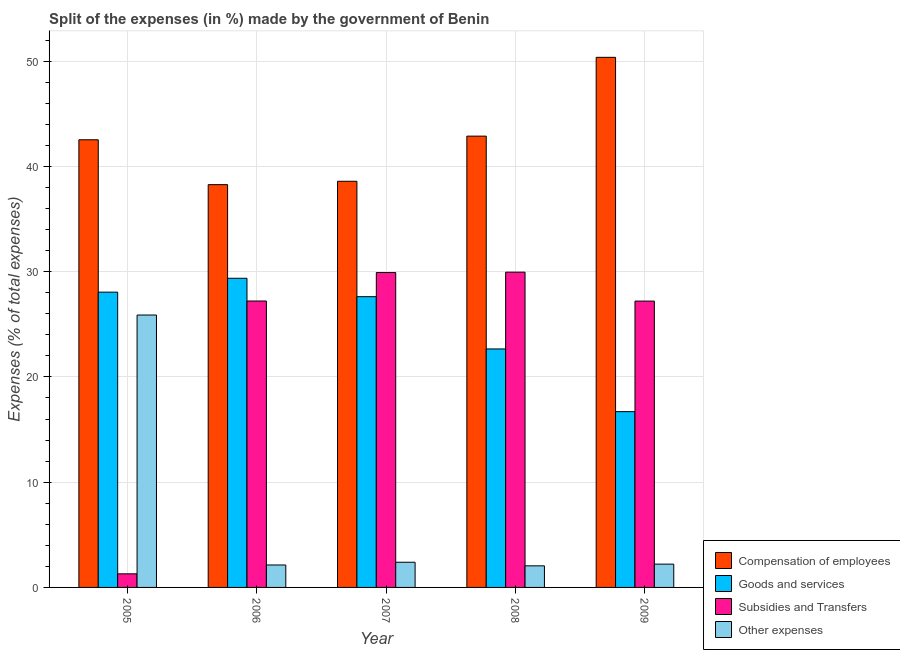How many different coloured bars are there?
Offer a terse response. 4. Are the number of bars per tick equal to the number of legend labels?
Offer a very short reply. Yes. Are the number of bars on each tick of the X-axis equal?
Provide a short and direct response. Yes. How many bars are there on the 2nd tick from the left?
Keep it short and to the point. 4. What is the label of the 2nd group of bars from the left?
Provide a short and direct response. 2006. What is the percentage of amount spent on subsidies in 2008?
Make the answer very short. 29.95. Across all years, what is the maximum percentage of amount spent on other expenses?
Provide a succinct answer. 25.88. Across all years, what is the minimum percentage of amount spent on compensation of employees?
Provide a succinct answer. 38.26. What is the total percentage of amount spent on compensation of employees in the graph?
Your answer should be compact. 212.61. What is the difference between the percentage of amount spent on compensation of employees in 2005 and that in 2007?
Make the answer very short. 3.94. What is the difference between the percentage of amount spent on compensation of employees in 2005 and the percentage of amount spent on goods and services in 2008?
Offer a terse response. -0.35. What is the average percentage of amount spent on compensation of employees per year?
Provide a succinct answer. 42.52. What is the ratio of the percentage of amount spent on compensation of employees in 2007 to that in 2008?
Your answer should be very brief. 0.9. What is the difference between the highest and the second highest percentage of amount spent on subsidies?
Make the answer very short. 0.03. What is the difference between the highest and the lowest percentage of amount spent on subsidies?
Your response must be concise. 28.66. In how many years, is the percentage of amount spent on compensation of employees greater than the average percentage of amount spent on compensation of employees taken over all years?
Provide a short and direct response. 3. What does the 3rd bar from the left in 2009 represents?
Offer a terse response. Subsidies and Transfers. What does the 2nd bar from the right in 2007 represents?
Ensure brevity in your answer.  Subsidies and Transfers. How many bars are there?
Give a very brief answer. 20. Are all the bars in the graph horizontal?
Offer a very short reply. No. Are the values on the major ticks of Y-axis written in scientific E-notation?
Give a very brief answer. No. Does the graph contain any zero values?
Offer a terse response. No. Where does the legend appear in the graph?
Your answer should be compact. Bottom right. How many legend labels are there?
Ensure brevity in your answer.  4. How are the legend labels stacked?
Make the answer very short. Vertical. What is the title of the graph?
Offer a terse response. Split of the expenses (in %) made by the government of Benin. What is the label or title of the X-axis?
Ensure brevity in your answer.  Year. What is the label or title of the Y-axis?
Your answer should be compact. Expenses (% of total expenses). What is the Expenses (% of total expenses) in Compensation of employees in 2005?
Your answer should be compact. 42.53. What is the Expenses (% of total expenses) in Goods and services in 2005?
Ensure brevity in your answer.  28.05. What is the Expenses (% of total expenses) in Subsidies and Transfers in 2005?
Keep it short and to the point. 1.29. What is the Expenses (% of total expenses) of Other expenses in 2005?
Offer a terse response. 25.88. What is the Expenses (% of total expenses) of Compensation of employees in 2006?
Your response must be concise. 38.26. What is the Expenses (% of total expenses) in Goods and services in 2006?
Your response must be concise. 29.37. What is the Expenses (% of total expenses) of Subsidies and Transfers in 2006?
Make the answer very short. 27.21. What is the Expenses (% of total expenses) in Other expenses in 2006?
Offer a very short reply. 2.13. What is the Expenses (% of total expenses) of Compensation of employees in 2007?
Keep it short and to the point. 38.59. What is the Expenses (% of total expenses) in Goods and services in 2007?
Offer a very short reply. 27.62. What is the Expenses (% of total expenses) of Subsidies and Transfers in 2007?
Offer a very short reply. 29.92. What is the Expenses (% of total expenses) of Other expenses in 2007?
Your answer should be compact. 2.39. What is the Expenses (% of total expenses) in Compensation of employees in 2008?
Make the answer very short. 42.87. What is the Expenses (% of total expenses) of Goods and services in 2008?
Your answer should be very brief. 22.66. What is the Expenses (% of total expenses) in Subsidies and Transfers in 2008?
Give a very brief answer. 29.95. What is the Expenses (% of total expenses) of Other expenses in 2008?
Your answer should be very brief. 2.05. What is the Expenses (% of total expenses) of Compensation of employees in 2009?
Offer a terse response. 50.36. What is the Expenses (% of total expenses) in Goods and services in 2009?
Your answer should be compact. 16.7. What is the Expenses (% of total expenses) of Subsidies and Transfers in 2009?
Your response must be concise. 27.2. What is the Expenses (% of total expenses) of Other expenses in 2009?
Ensure brevity in your answer.  2.21. Across all years, what is the maximum Expenses (% of total expenses) of Compensation of employees?
Your answer should be very brief. 50.36. Across all years, what is the maximum Expenses (% of total expenses) in Goods and services?
Make the answer very short. 29.37. Across all years, what is the maximum Expenses (% of total expenses) in Subsidies and Transfers?
Your response must be concise. 29.95. Across all years, what is the maximum Expenses (% of total expenses) in Other expenses?
Your answer should be very brief. 25.88. Across all years, what is the minimum Expenses (% of total expenses) of Compensation of employees?
Make the answer very short. 38.26. Across all years, what is the minimum Expenses (% of total expenses) in Goods and services?
Your answer should be compact. 16.7. Across all years, what is the minimum Expenses (% of total expenses) in Subsidies and Transfers?
Ensure brevity in your answer.  1.29. Across all years, what is the minimum Expenses (% of total expenses) of Other expenses?
Your answer should be very brief. 2.05. What is the total Expenses (% of total expenses) in Compensation of employees in the graph?
Provide a succinct answer. 212.61. What is the total Expenses (% of total expenses) in Goods and services in the graph?
Offer a very short reply. 124.4. What is the total Expenses (% of total expenses) of Subsidies and Transfers in the graph?
Your response must be concise. 115.57. What is the total Expenses (% of total expenses) of Other expenses in the graph?
Your answer should be compact. 34.67. What is the difference between the Expenses (% of total expenses) in Compensation of employees in 2005 and that in 2006?
Your response must be concise. 4.26. What is the difference between the Expenses (% of total expenses) of Goods and services in 2005 and that in 2006?
Make the answer very short. -1.32. What is the difference between the Expenses (% of total expenses) of Subsidies and Transfers in 2005 and that in 2006?
Your answer should be compact. -25.92. What is the difference between the Expenses (% of total expenses) of Other expenses in 2005 and that in 2006?
Keep it short and to the point. 23.75. What is the difference between the Expenses (% of total expenses) in Compensation of employees in 2005 and that in 2007?
Your answer should be very brief. 3.94. What is the difference between the Expenses (% of total expenses) of Goods and services in 2005 and that in 2007?
Your answer should be very brief. 0.43. What is the difference between the Expenses (% of total expenses) in Subsidies and Transfers in 2005 and that in 2007?
Offer a very short reply. -28.62. What is the difference between the Expenses (% of total expenses) in Other expenses in 2005 and that in 2007?
Provide a short and direct response. 23.49. What is the difference between the Expenses (% of total expenses) of Compensation of employees in 2005 and that in 2008?
Your answer should be very brief. -0.35. What is the difference between the Expenses (% of total expenses) in Goods and services in 2005 and that in 2008?
Provide a succinct answer. 5.4. What is the difference between the Expenses (% of total expenses) in Subsidies and Transfers in 2005 and that in 2008?
Ensure brevity in your answer.  -28.66. What is the difference between the Expenses (% of total expenses) of Other expenses in 2005 and that in 2008?
Your answer should be very brief. 23.83. What is the difference between the Expenses (% of total expenses) in Compensation of employees in 2005 and that in 2009?
Your response must be concise. -7.83. What is the difference between the Expenses (% of total expenses) of Goods and services in 2005 and that in 2009?
Keep it short and to the point. 11.35. What is the difference between the Expenses (% of total expenses) in Subsidies and Transfers in 2005 and that in 2009?
Your answer should be very brief. -25.91. What is the difference between the Expenses (% of total expenses) of Other expenses in 2005 and that in 2009?
Provide a succinct answer. 23.67. What is the difference between the Expenses (% of total expenses) of Compensation of employees in 2006 and that in 2007?
Offer a very short reply. -0.32. What is the difference between the Expenses (% of total expenses) in Goods and services in 2006 and that in 2007?
Offer a terse response. 1.75. What is the difference between the Expenses (% of total expenses) of Subsidies and Transfers in 2006 and that in 2007?
Ensure brevity in your answer.  -2.71. What is the difference between the Expenses (% of total expenses) of Other expenses in 2006 and that in 2007?
Give a very brief answer. -0.26. What is the difference between the Expenses (% of total expenses) in Compensation of employees in 2006 and that in 2008?
Give a very brief answer. -4.61. What is the difference between the Expenses (% of total expenses) in Goods and services in 2006 and that in 2008?
Provide a succinct answer. 6.71. What is the difference between the Expenses (% of total expenses) in Subsidies and Transfers in 2006 and that in 2008?
Your response must be concise. -2.74. What is the difference between the Expenses (% of total expenses) in Other expenses in 2006 and that in 2008?
Your answer should be compact. 0.08. What is the difference between the Expenses (% of total expenses) in Compensation of employees in 2006 and that in 2009?
Your answer should be compact. -12.1. What is the difference between the Expenses (% of total expenses) in Goods and services in 2006 and that in 2009?
Your response must be concise. 12.67. What is the difference between the Expenses (% of total expenses) in Subsidies and Transfers in 2006 and that in 2009?
Give a very brief answer. 0.01. What is the difference between the Expenses (% of total expenses) in Other expenses in 2006 and that in 2009?
Provide a succinct answer. -0.08. What is the difference between the Expenses (% of total expenses) in Compensation of employees in 2007 and that in 2008?
Keep it short and to the point. -4.29. What is the difference between the Expenses (% of total expenses) of Goods and services in 2007 and that in 2008?
Ensure brevity in your answer.  4.97. What is the difference between the Expenses (% of total expenses) of Subsidies and Transfers in 2007 and that in 2008?
Offer a terse response. -0.03. What is the difference between the Expenses (% of total expenses) in Other expenses in 2007 and that in 2008?
Make the answer very short. 0.34. What is the difference between the Expenses (% of total expenses) in Compensation of employees in 2007 and that in 2009?
Offer a very short reply. -11.78. What is the difference between the Expenses (% of total expenses) in Goods and services in 2007 and that in 2009?
Provide a short and direct response. 10.92. What is the difference between the Expenses (% of total expenses) in Subsidies and Transfers in 2007 and that in 2009?
Give a very brief answer. 2.71. What is the difference between the Expenses (% of total expenses) in Other expenses in 2007 and that in 2009?
Offer a very short reply. 0.18. What is the difference between the Expenses (% of total expenses) in Compensation of employees in 2008 and that in 2009?
Ensure brevity in your answer.  -7.49. What is the difference between the Expenses (% of total expenses) of Goods and services in 2008 and that in 2009?
Your answer should be very brief. 5.96. What is the difference between the Expenses (% of total expenses) of Subsidies and Transfers in 2008 and that in 2009?
Offer a terse response. 2.75. What is the difference between the Expenses (% of total expenses) of Other expenses in 2008 and that in 2009?
Give a very brief answer. -0.16. What is the difference between the Expenses (% of total expenses) of Compensation of employees in 2005 and the Expenses (% of total expenses) of Goods and services in 2006?
Offer a terse response. 13.16. What is the difference between the Expenses (% of total expenses) in Compensation of employees in 2005 and the Expenses (% of total expenses) in Subsidies and Transfers in 2006?
Your answer should be compact. 15.32. What is the difference between the Expenses (% of total expenses) in Compensation of employees in 2005 and the Expenses (% of total expenses) in Other expenses in 2006?
Provide a succinct answer. 40.39. What is the difference between the Expenses (% of total expenses) of Goods and services in 2005 and the Expenses (% of total expenses) of Subsidies and Transfers in 2006?
Provide a short and direct response. 0.84. What is the difference between the Expenses (% of total expenses) of Goods and services in 2005 and the Expenses (% of total expenses) of Other expenses in 2006?
Give a very brief answer. 25.92. What is the difference between the Expenses (% of total expenses) in Subsidies and Transfers in 2005 and the Expenses (% of total expenses) in Other expenses in 2006?
Provide a short and direct response. -0.84. What is the difference between the Expenses (% of total expenses) of Compensation of employees in 2005 and the Expenses (% of total expenses) of Goods and services in 2007?
Your answer should be compact. 14.91. What is the difference between the Expenses (% of total expenses) in Compensation of employees in 2005 and the Expenses (% of total expenses) in Subsidies and Transfers in 2007?
Your answer should be compact. 12.61. What is the difference between the Expenses (% of total expenses) in Compensation of employees in 2005 and the Expenses (% of total expenses) in Other expenses in 2007?
Keep it short and to the point. 40.14. What is the difference between the Expenses (% of total expenses) of Goods and services in 2005 and the Expenses (% of total expenses) of Subsidies and Transfers in 2007?
Provide a short and direct response. -1.86. What is the difference between the Expenses (% of total expenses) in Goods and services in 2005 and the Expenses (% of total expenses) in Other expenses in 2007?
Provide a short and direct response. 25.66. What is the difference between the Expenses (% of total expenses) in Subsidies and Transfers in 2005 and the Expenses (% of total expenses) in Other expenses in 2007?
Your response must be concise. -1.1. What is the difference between the Expenses (% of total expenses) of Compensation of employees in 2005 and the Expenses (% of total expenses) of Goods and services in 2008?
Your answer should be very brief. 19.87. What is the difference between the Expenses (% of total expenses) in Compensation of employees in 2005 and the Expenses (% of total expenses) in Subsidies and Transfers in 2008?
Provide a short and direct response. 12.58. What is the difference between the Expenses (% of total expenses) of Compensation of employees in 2005 and the Expenses (% of total expenses) of Other expenses in 2008?
Ensure brevity in your answer.  40.48. What is the difference between the Expenses (% of total expenses) in Goods and services in 2005 and the Expenses (% of total expenses) in Subsidies and Transfers in 2008?
Your response must be concise. -1.9. What is the difference between the Expenses (% of total expenses) in Goods and services in 2005 and the Expenses (% of total expenses) in Other expenses in 2008?
Offer a terse response. 26. What is the difference between the Expenses (% of total expenses) in Subsidies and Transfers in 2005 and the Expenses (% of total expenses) in Other expenses in 2008?
Ensure brevity in your answer.  -0.76. What is the difference between the Expenses (% of total expenses) in Compensation of employees in 2005 and the Expenses (% of total expenses) in Goods and services in 2009?
Give a very brief answer. 25.83. What is the difference between the Expenses (% of total expenses) of Compensation of employees in 2005 and the Expenses (% of total expenses) of Subsidies and Transfers in 2009?
Give a very brief answer. 15.32. What is the difference between the Expenses (% of total expenses) of Compensation of employees in 2005 and the Expenses (% of total expenses) of Other expenses in 2009?
Make the answer very short. 40.31. What is the difference between the Expenses (% of total expenses) of Goods and services in 2005 and the Expenses (% of total expenses) of Subsidies and Transfers in 2009?
Give a very brief answer. 0.85. What is the difference between the Expenses (% of total expenses) of Goods and services in 2005 and the Expenses (% of total expenses) of Other expenses in 2009?
Keep it short and to the point. 25.84. What is the difference between the Expenses (% of total expenses) in Subsidies and Transfers in 2005 and the Expenses (% of total expenses) in Other expenses in 2009?
Provide a succinct answer. -0.92. What is the difference between the Expenses (% of total expenses) in Compensation of employees in 2006 and the Expenses (% of total expenses) in Goods and services in 2007?
Offer a very short reply. 10.64. What is the difference between the Expenses (% of total expenses) of Compensation of employees in 2006 and the Expenses (% of total expenses) of Subsidies and Transfers in 2007?
Provide a succinct answer. 8.35. What is the difference between the Expenses (% of total expenses) of Compensation of employees in 2006 and the Expenses (% of total expenses) of Other expenses in 2007?
Your answer should be compact. 35.87. What is the difference between the Expenses (% of total expenses) of Goods and services in 2006 and the Expenses (% of total expenses) of Subsidies and Transfers in 2007?
Offer a terse response. -0.54. What is the difference between the Expenses (% of total expenses) of Goods and services in 2006 and the Expenses (% of total expenses) of Other expenses in 2007?
Your answer should be very brief. 26.98. What is the difference between the Expenses (% of total expenses) in Subsidies and Transfers in 2006 and the Expenses (% of total expenses) in Other expenses in 2007?
Ensure brevity in your answer.  24.82. What is the difference between the Expenses (% of total expenses) of Compensation of employees in 2006 and the Expenses (% of total expenses) of Goods and services in 2008?
Make the answer very short. 15.61. What is the difference between the Expenses (% of total expenses) of Compensation of employees in 2006 and the Expenses (% of total expenses) of Subsidies and Transfers in 2008?
Give a very brief answer. 8.31. What is the difference between the Expenses (% of total expenses) in Compensation of employees in 2006 and the Expenses (% of total expenses) in Other expenses in 2008?
Offer a terse response. 36.21. What is the difference between the Expenses (% of total expenses) in Goods and services in 2006 and the Expenses (% of total expenses) in Subsidies and Transfers in 2008?
Ensure brevity in your answer.  -0.58. What is the difference between the Expenses (% of total expenses) in Goods and services in 2006 and the Expenses (% of total expenses) in Other expenses in 2008?
Offer a terse response. 27.32. What is the difference between the Expenses (% of total expenses) in Subsidies and Transfers in 2006 and the Expenses (% of total expenses) in Other expenses in 2008?
Ensure brevity in your answer.  25.16. What is the difference between the Expenses (% of total expenses) in Compensation of employees in 2006 and the Expenses (% of total expenses) in Goods and services in 2009?
Keep it short and to the point. 21.56. What is the difference between the Expenses (% of total expenses) in Compensation of employees in 2006 and the Expenses (% of total expenses) in Subsidies and Transfers in 2009?
Your response must be concise. 11.06. What is the difference between the Expenses (% of total expenses) in Compensation of employees in 2006 and the Expenses (% of total expenses) in Other expenses in 2009?
Make the answer very short. 36.05. What is the difference between the Expenses (% of total expenses) in Goods and services in 2006 and the Expenses (% of total expenses) in Subsidies and Transfers in 2009?
Keep it short and to the point. 2.17. What is the difference between the Expenses (% of total expenses) of Goods and services in 2006 and the Expenses (% of total expenses) of Other expenses in 2009?
Keep it short and to the point. 27.16. What is the difference between the Expenses (% of total expenses) in Subsidies and Transfers in 2006 and the Expenses (% of total expenses) in Other expenses in 2009?
Your response must be concise. 25. What is the difference between the Expenses (% of total expenses) of Compensation of employees in 2007 and the Expenses (% of total expenses) of Goods and services in 2008?
Offer a terse response. 15.93. What is the difference between the Expenses (% of total expenses) in Compensation of employees in 2007 and the Expenses (% of total expenses) in Subsidies and Transfers in 2008?
Offer a very short reply. 8.64. What is the difference between the Expenses (% of total expenses) in Compensation of employees in 2007 and the Expenses (% of total expenses) in Other expenses in 2008?
Provide a short and direct response. 36.53. What is the difference between the Expenses (% of total expenses) of Goods and services in 2007 and the Expenses (% of total expenses) of Subsidies and Transfers in 2008?
Make the answer very short. -2.33. What is the difference between the Expenses (% of total expenses) of Goods and services in 2007 and the Expenses (% of total expenses) of Other expenses in 2008?
Offer a terse response. 25.57. What is the difference between the Expenses (% of total expenses) in Subsidies and Transfers in 2007 and the Expenses (% of total expenses) in Other expenses in 2008?
Offer a terse response. 27.86. What is the difference between the Expenses (% of total expenses) of Compensation of employees in 2007 and the Expenses (% of total expenses) of Goods and services in 2009?
Offer a terse response. 21.89. What is the difference between the Expenses (% of total expenses) in Compensation of employees in 2007 and the Expenses (% of total expenses) in Subsidies and Transfers in 2009?
Ensure brevity in your answer.  11.38. What is the difference between the Expenses (% of total expenses) of Compensation of employees in 2007 and the Expenses (% of total expenses) of Other expenses in 2009?
Give a very brief answer. 36.37. What is the difference between the Expenses (% of total expenses) in Goods and services in 2007 and the Expenses (% of total expenses) in Subsidies and Transfers in 2009?
Offer a very short reply. 0.42. What is the difference between the Expenses (% of total expenses) of Goods and services in 2007 and the Expenses (% of total expenses) of Other expenses in 2009?
Your answer should be very brief. 25.41. What is the difference between the Expenses (% of total expenses) of Subsidies and Transfers in 2007 and the Expenses (% of total expenses) of Other expenses in 2009?
Your response must be concise. 27.7. What is the difference between the Expenses (% of total expenses) of Compensation of employees in 2008 and the Expenses (% of total expenses) of Goods and services in 2009?
Ensure brevity in your answer.  26.17. What is the difference between the Expenses (% of total expenses) of Compensation of employees in 2008 and the Expenses (% of total expenses) of Subsidies and Transfers in 2009?
Provide a short and direct response. 15.67. What is the difference between the Expenses (% of total expenses) in Compensation of employees in 2008 and the Expenses (% of total expenses) in Other expenses in 2009?
Give a very brief answer. 40.66. What is the difference between the Expenses (% of total expenses) in Goods and services in 2008 and the Expenses (% of total expenses) in Subsidies and Transfers in 2009?
Your response must be concise. -4.55. What is the difference between the Expenses (% of total expenses) in Goods and services in 2008 and the Expenses (% of total expenses) in Other expenses in 2009?
Provide a short and direct response. 20.44. What is the difference between the Expenses (% of total expenses) in Subsidies and Transfers in 2008 and the Expenses (% of total expenses) in Other expenses in 2009?
Make the answer very short. 27.74. What is the average Expenses (% of total expenses) in Compensation of employees per year?
Your response must be concise. 42.52. What is the average Expenses (% of total expenses) of Goods and services per year?
Provide a short and direct response. 24.88. What is the average Expenses (% of total expenses) in Subsidies and Transfers per year?
Offer a very short reply. 23.11. What is the average Expenses (% of total expenses) in Other expenses per year?
Make the answer very short. 6.93. In the year 2005, what is the difference between the Expenses (% of total expenses) of Compensation of employees and Expenses (% of total expenses) of Goods and services?
Ensure brevity in your answer.  14.47. In the year 2005, what is the difference between the Expenses (% of total expenses) of Compensation of employees and Expenses (% of total expenses) of Subsidies and Transfers?
Provide a succinct answer. 41.24. In the year 2005, what is the difference between the Expenses (% of total expenses) of Compensation of employees and Expenses (% of total expenses) of Other expenses?
Keep it short and to the point. 16.65. In the year 2005, what is the difference between the Expenses (% of total expenses) of Goods and services and Expenses (% of total expenses) of Subsidies and Transfers?
Offer a very short reply. 26.76. In the year 2005, what is the difference between the Expenses (% of total expenses) in Goods and services and Expenses (% of total expenses) in Other expenses?
Provide a succinct answer. 2.17. In the year 2005, what is the difference between the Expenses (% of total expenses) of Subsidies and Transfers and Expenses (% of total expenses) of Other expenses?
Provide a succinct answer. -24.59. In the year 2006, what is the difference between the Expenses (% of total expenses) in Compensation of employees and Expenses (% of total expenses) in Goods and services?
Your answer should be compact. 8.89. In the year 2006, what is the difference between the Expenses (% of total expenses) in Compensation of employees and Expenses (% of total expenses) in Subsidies and Transfers?
Provide a succinct answer. 11.05. In the year 2006, what is the difference between the Expenses (% of total expenses) of Compensation of employees and Expenses (% of total expenses) of Other expenses?
Keep it short and to the point. 36.13. In the year 2006, what is the difference between the Expenses (% of total expenses) in Goods and services and Expenses (% of total expenses) in Subsidies and Transfers?
Give a very brief answer. 2.16. In the year 2006, what is the difference between the Expenses (% of total expenses) of Goods and services and Expenses (% of total expenses) of Other expenses?
Make the answer very short. 27.24. In the year 2006, what is the difference between the Expenses (% of total expenses) in Subsidies and Transfers and Expenses (% of total expenses) in Other expenses?
Offer a very short reply. 25.08. In the year 2007, what is the difference between the Expenses (% of total expenses) in Compensation of employees and Expenses (% of total expenses) in Goods and services?
Your answer should be compact. 10.96. In the year 2007, what is the difference between the Expenses (% of total expenses) of Compensation of employees and Expenses (% of total expenses) of Subsidies and Transfers?
Provide a succinct answer. 8.67. In the year 2007, what is the difference between the Expenses (% of total expenses) in Compensation of employees and Expenses (% of total expenses) in Other expenses?
Provide a short and direct response. 36.19. In the year 2007, what is the difference between the Expenses (% of total expenses) in Goods and services and Expenses (% of total expenses) in Subsidies and Transfers?
Provide a succinct answer. -2.29. In the year 2007, what is the difference between the Expenses (% of total expenses) in Goods and services and Expenses (% of total expenses) in Other expenses?
Your answer should be compact. 25.23. In the year 2007, what is the difference between the Expenses (% of total expenses) in Subsidies and Transfers and Expenses (% of total expenses) in Other expenses?
Offer a very short reply. 27.52. In the year 2008, what is the difference between the Expenses (% of total expenses) of Compensation of employees and Expenses (% of total expenses) of Goods and services?
Your answer should be very brief. 20.22. In the year 2008, what is the difference between the Expenses (% of total expenses) in Compensation of employees and Expenses (% of total expenses) in Subsidies and Transfers?
Offer a terse response. 12.92. In the year 2008, what is the difference between the Expenses (% of total expenses) of Compensation of employees and Expenses (% of total expenses) of Other expenses?
Provide a short and direct response. 40.82. In the year 2008, what is the difference between the Expenses (% of total expenses) in Goods and services and Expenses (% of total expenses) in Subsidies and Transfers?
Give a very brief answer. -7.29. In the year 2008, what is the difference between the Expenses (% of total expenses) of Goods and services and Expenses (% of total expenses) of Other expenses?
Your answer should be compact. 20.61. In the year 2008, what is the difference between the Expenses (% of total expenses) of Subsidies and Transfers and Expenses (% of total expenses) of Other expenses?
Offer a terse response. 27.9. In the year 2009, what is the difference between the Expenses (% of total expenses) of Compensation of employees and Expenses (% of total expenses) of Goods and services?
Provide a succinct answer. 33.66. In the year 2009, what is the difference between the Expenses (% of total expenses) of Compensation of employees and Expenses (% of total expenses) of Subsidies and Transfers?
Provide a short and direct response. 23.16. In the year 2009, what is the difference between the Expenses (% of total expenses) in Compensation of employees and Expenses (% of total expenses) in Other expenses?
Ensure brevity in your answer.  48.15. In the year 2009, what is the difference between the Expenses (% of total expenses) of Goods and services and Expenses (% of total expenses) of Subsidies and Transfers?
Offer a very short reply. -10.5. In the year 2009, what is the difference between the Expenses (% of total expenses) of Goods and services and Expenses (% of total expenses) of Other expenses?
Give a very brief answer. 14.49. In the year 2009, what is the difference between the Expenses (% of total expenses) of Subsidies and Transfers and Expenses (% of total expenses) of Other expenses?
Your answer should be very brief. 24.99. What is the ratio of the Expenses (% of total expenses) of Compensation of employees in 2005 to that in 2006?
Ensure brevity in your answer.  1.11. What is the ratio of the Expenses (% of total expenses) in Goods and services in 2005 to that in 2006?
Your answer should be very brief. 0.96. What is the ratio of the Expenses (% of total expenses) of Subsidies and Transfers in 2005 to that in 2006?
Your answer should be very brief. 0.05. What is the ratio of the Expenses (% of total expenses) in Other expenses in 2005 to that in 2006?
Make the answer very short. 12.14. What is the ratio of the Expenses (% of total expenses) of Compensation of employees in 2005 to that in 2007?
Offer a very short reply. 1.1. What is the ratio of the Expenses (% of total expenses) in Goods and services in 2005 to that in 2007?
Make the answer very short. 1.02. What is the ratio of the Expenses (% of total expenses) of Subsidies and Transfers in 2005 to that in 2007?
Offer a very short reply. 0.04. What is the ratio of the Expenses (% of total expenses) of Other expenses in 2005 to that in 2007?
Offer a terse response. 10.82. What is the ratio of the Expenses (% of total expenses) of Goods and services in 2005 to that in 2008?
Your answer should be very brief. 1.24. What is the ratio of the Expenses (% of total expenses) in Subsidies and Transfers in 2005 to that in 2008?
Keep it short and to the point. 0.04. What is the ratio of the Expenses (% of total expenses) in Other expenses in 2005 to that in 2008?
Your answer should be very brief. 12.62. What is the ratio of the Expenses (% of total expenses) in Compensation of employees in 2005 to that in 2009?
Give a very brief answer. 0.84. What is the ratio of the Expenses (% of total expenses) of Goods and services in 2005 to that in 2009?
Provide a short and direct response. 1.68. What is the ratio of the Expenses (% of total expenses) of Subsidies and Transfers in 2005 to that in 2009?
Keep it short and to the point. 0.05. What is the ratio of the Expenses (% of total expenses) of Other expenses in 2005 to that in 2009?
Make the answer very short. 11.7. What is the ratio of the Expenses (% of total expenses) in Compensation of employees in 2006 to that in 2007?
Give a very brief answer. 0.99. What is the ratio of the Expenses (% of total expenses) in Goods and services in 2006 to that in 2007?
Offer a very short reply. 1.06. What is the ratio of the Expenses (% of total expenses) of Subsidies and Transfers in 2006 to that in 2007?
Your answer should be compact. 0.91. What is the ratio of the Expenses (% of total expenses) of Other expenses in 2006 to that in 2007?
Ensure brevity in your answer.  0.89. What is the ratio of the Expenses (% of total expenses) of Compensation of employees in 2006 to that in 2008?
Make the answer very short. 0.89. What is the ratio of the Expenses (% of total expenses) in Goods and services in 2006 to that in 2008?
Keep it short and to the point. 1.3. What is the ratio of the Expenses (% of total expenses) of Subsidies and Transfers in 2006 to that in 2008?
Ensure brevity in your answer.  0.91. What is the ratio of the Expenses (% of total expenses) in Other expenses in 2006 to that in 2008?
Your answer should be compact. 1.04. What is the ratio of the Expenses (% of total expenses) in Compensation of employees in 2006 to that in 2009?
Provide a short and direct response. 0.76. What is the ratio of the Expenses (% of total expenses) of Goods and services in 2006 to that in 2009?
Your response must be concise. 1.76. What is the ratio of the Expenses (% of total expenses) in Other expenses in 2006 to that in 2009?
Keep it short and to the point. 0.96. What is the ratio of the Expenses (% of total expenses) of Compensation of employees in 2007 to that in 2008?
Ensure brevity in your answer.  0.9. What is the ratio of the Expenses (% of total expenses) of Goods and services in 2007 to that in 2008?
Give a very brief answer. 1.22. What is the ratio of the Expenses (% of total expenses) in Subsidies and Transfers in 2007 to that in 2008?
Keep it short and to the point. 1. What is the ratio of the Expenses (% of total expenses) of Other expenses in 2007 to that in 2008?
Give a very brief answer. 1.17. What is the ratio of the Expenses (% of total expenses) of Compensation of employees in 2007 to that in 2009?
Your answer should be compact. 0.77. What is the ratio of the Expenses (% of total expenses) in Goods and services in 2007 to that in 2009?
Give a very brief answer. 1.65. What is the ratio of the Expenses (% of total expenses) of Subsidies and Transfers in 2007 to that in 2009?
Offer a terse response. 1.1. What is the ratio of the Expenses (% of total expenses) of Other expenses in 2007 to that in 2009?
Give a very brief answer. 1.08. What is the ratio of the Expenses (% of total expenses) of Compensation of employees in 2008 to that in 2009?
Make the answer very short. 0.85. What is the ratio of the Expenses (% of total expenses) in Goods and services in 2008 to that in 2009?
Your answer should be very brief. 1.36. What is the ratio of the Expenses (% of total expenses) in Subsidies and Transfers in 2008 to that in 2009?
Offer a very short reply. 1.1. What is the ratio of the Expenses (% of total expenses) of Other expenses in 2008 to that in 2009?
Give a very brief answer. 0.93. What is the difference between the highest and the second highest Expenses (% of total expenses) in Compensation of employees?
Offer a terse response. 7.49. What is the difference between the highest and the second highest Expenses (% of total expenses) in Goods and services?
Keep it short and to the point. 1.32. What is the difference between the highest and the second highest Expenses (% of total expenses) in Subsidies and Transfers?
Offer a terse response. 0.03. What is the difference between the highest and the second highest Expenses (% of total expenses) of Other expenses?
Keep it short and to the point. 23.49. What is the difference between the highest and the lowest Expenses (% of total expenses) in Compensation of employees?
Give a very brief answer. 12.1. What is the difference between the highest and the lowest Expenses (% of total expenses) of Goods and services?
Your answer should be compact. 12.67. What is the difference between the highest and the lowest Expenses (% of total expenses) in Subsidies and Transfers?
Make the answer very short. 28.66. What is the difference between the highest and the lowest Expenses (% of total expenses) of Other expenses?
Your answer should be compact. 23.83. 